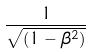<formula> <loc_0><loc_0><loc_500><loc_500>\frac { 1 } { \sqrt { ( 1 - \beta ^ { 2 } ) } }</formula> 